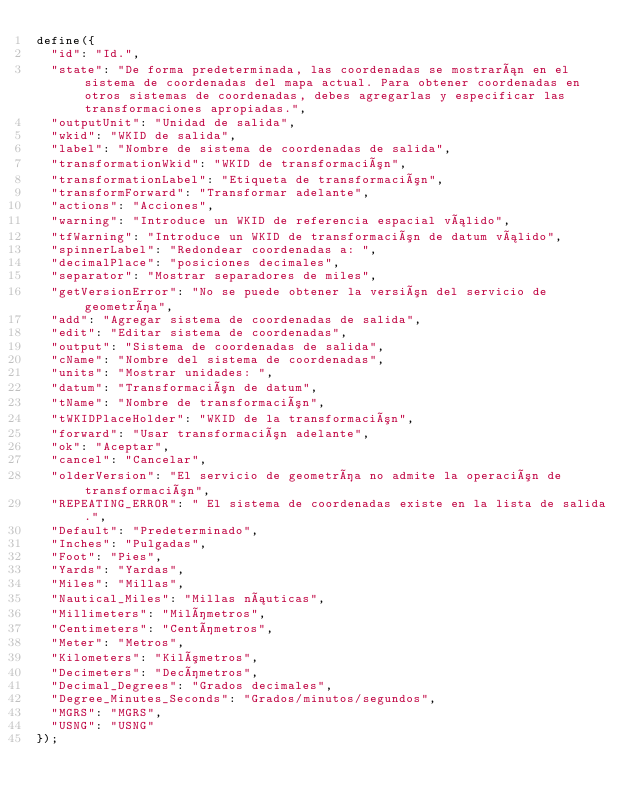Convert code to text. <code><loc_0><loc_0><loc_500><loc_500><_JavaScript_>define({
  "id": "Id.",
  "state": "De forma predeterminada, las coordenadas se mostrarán en el sistema de coordenadas del mapa actual. Para obtener coordenadas en otros sistemas de coordenadas, debes agregarlas y especificar las transformaciones apropiadas.",
  "outputUnit": "Unidad de salida",
  "wkid": "WKID de salida",
  "label": "Nombre de sistema de coordenadas de salida",
  "transformationWkid": "WKID de transformación",
  "transformationLabel": "Etiqueta de transformación",
  "transformForward": "Transformar adelante",
  "actions": "Acciones",
  "warning": "Introduce un WKID de referencia espacial válido",
  "tfWarning": "Introduce un WKID de transformación de datum válido",
  "spinnerLabel": "Redondear coordenadas a: ",
  "decimalPlace": "posiciones decimales",
  "separator": "Mostrar separadores de miles",
  "getVersionError": "No se puede obtener la versión del servicio de geometría",
  "add": "Agregar sistema de coordenadas de salida",
  "edit": "Editar sistema de coordenadas",
  "output": "Sistema de coordenadas de salida",
  "cName": "Nombre del sistema de coordenadas",
  "units": "Mostrar unidades: ",
  "datum": "Transformación de datum",
  "tName": "Nombre de transformación",
  "tWKIDPlaceHolder": "WKID de la transformación",
  "forward": "Usar transformación adelante",
  "ok": "Aceptar",
  "cancel": "Cancelar",
  "olderVersion": "El servicio de geometría no admite la operación de transformación",
  "REPEATING_ERROR": " El sistema de coordenadas existe en la lista de salida.",
  "Default": "Predeterminado",
  "Inches": "Pulgadas",
  "Foot": "Pies",
  "Yards": "Yardas",
  "Miles": "Millas",
  "Nautical_Miles": "Millas náuticas",
  "Millimeters": "Milímetros",
  "Centimeters": "Centímetros",
  "Meter": "Metros",
  "Kilometers": "Kilómetros",
  "Decimeters": "Decímetros",
  "Decimal_Degrees": "Grados decimales",
  "Degree_Minutes_Seconds": "Grados/minutos/segundos",
  "MGRS": "MGRS",
  "USNG": "USNG"
});</code> 